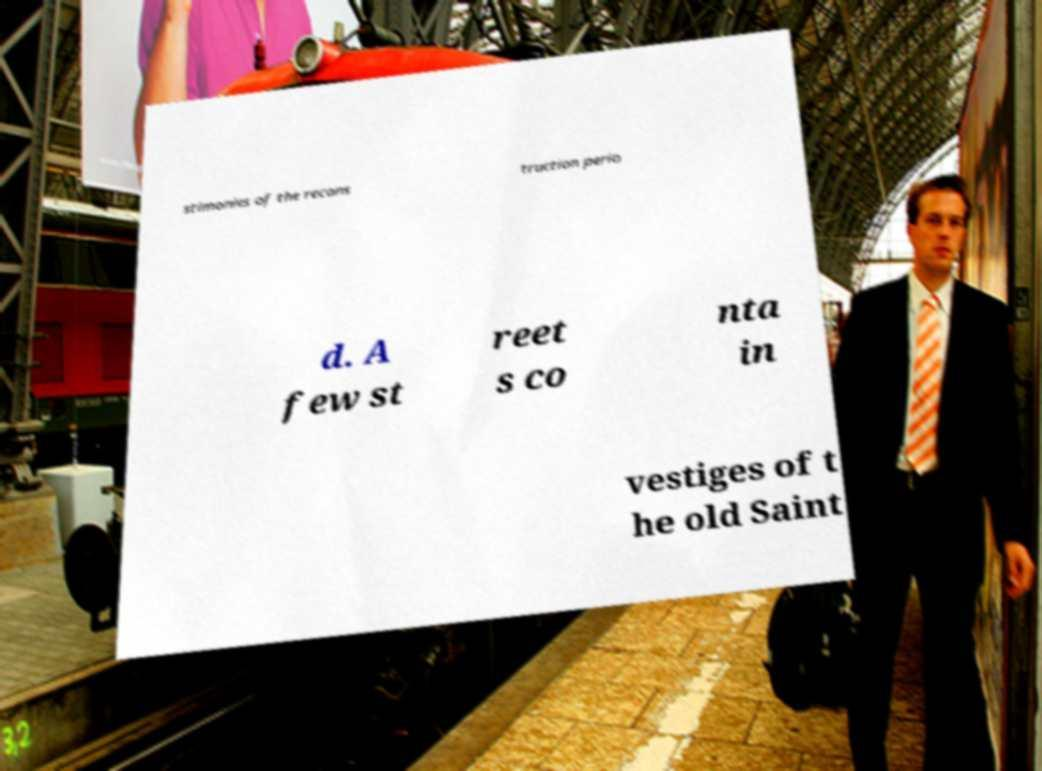Could you extract and type out the text from this image? stimonies of the recons truction perio d. A few st reet s co nta in vestiges of t he old Saint 